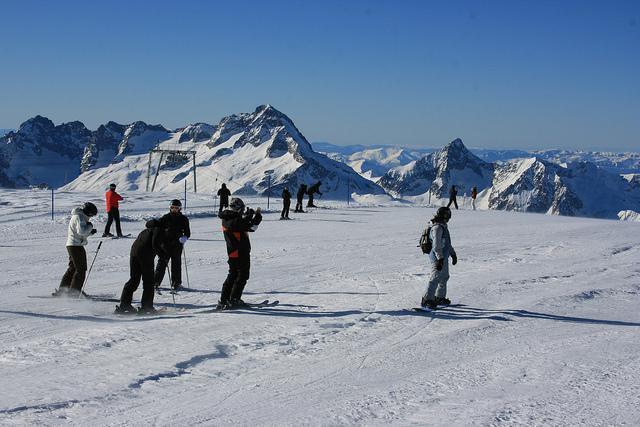How many people are there?
Give a very brief answer. 3. 